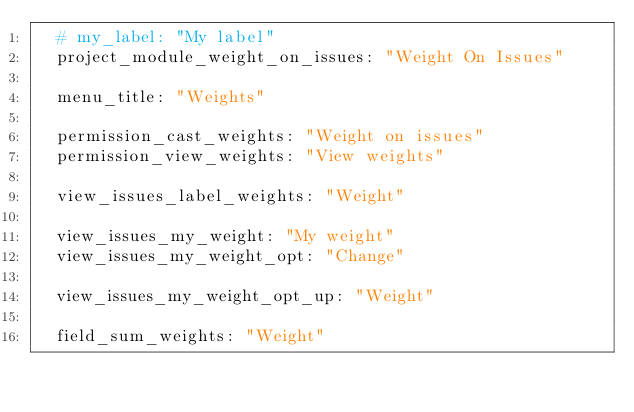Convert code to text. <code><loc_0><loc_0><loc_500><loc_500><_YAML_>  # my_label: "My label"
  project_module_weight_on_issues: "Weight On Issues"
  
  menu_title: "Weights"

  permission_cast_weights: "Weight on issues"  
  permission_view_weights: "View weights"
    
  view_issues_label_weights: "Weight"

  view_issues_my_weight: "My weight"
  view_issues_my_weight_opt: "Change"
  
  view_issues_my_weight_opt_up: "Weight"

  field_sum_weights: "Weight"
  </code> 